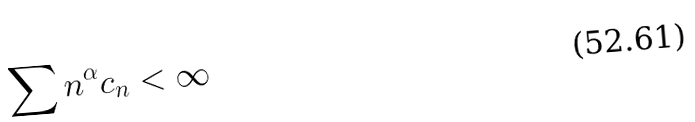Convert formula to latex. <formula><loc_0><loc_0><loc_500><loc_500>\sum n ^ { \alpha } c _ { n } < \infty</formula> 